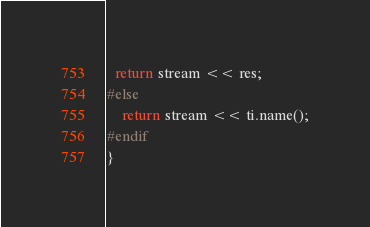Convert code to text. <code><loc_0><loc_0><loc_500><loc_500><_C++_>  return stream << res;
#else 
	return stream << ti.name();
#endif
}
</code> 